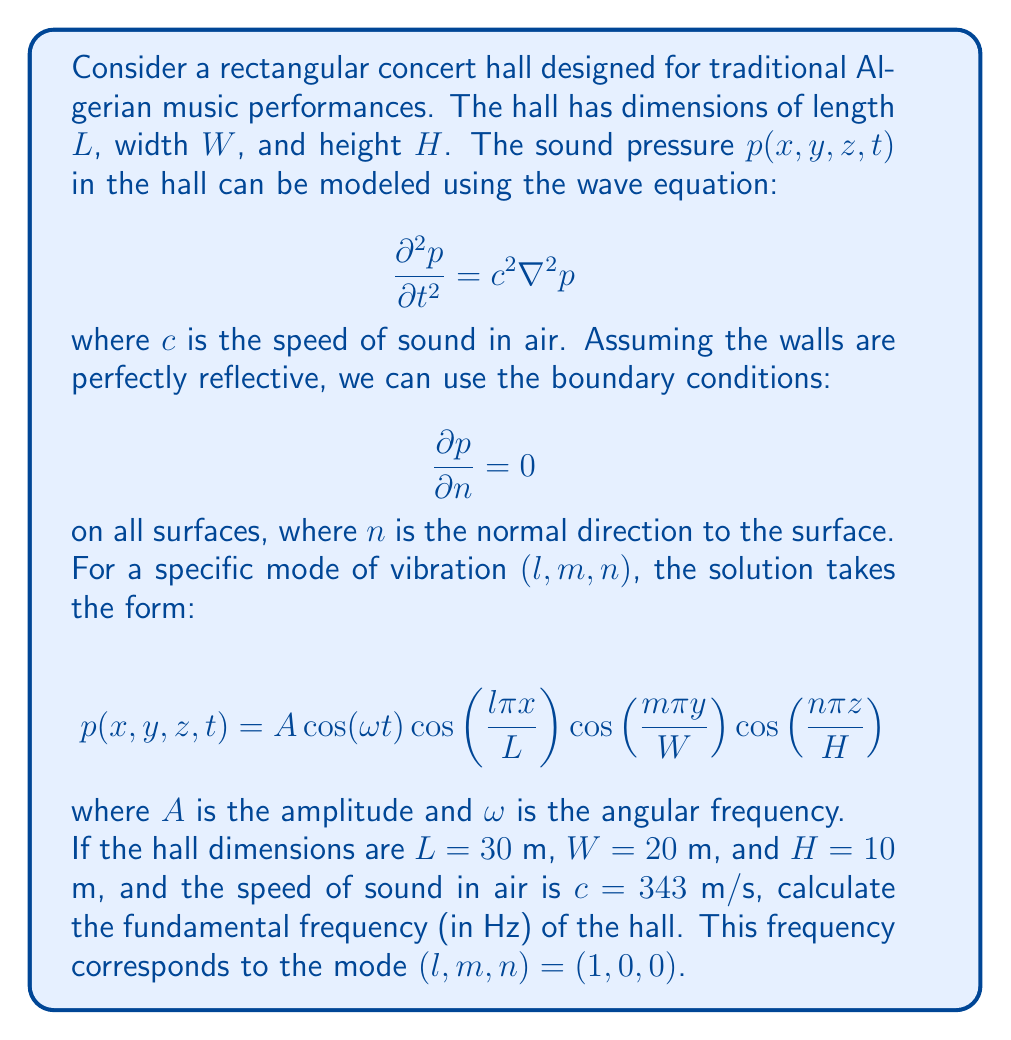Help me with this question. To solve this problem, we'll follow these steps:

1) The general relationship between frequency $f$, wavelength $\lambda$, and speed of sound $c$ is:
   
   $$c = f\lambda$$

2) For the fundamental mode $(1,0,0)$, the wavelength is twice the length of the hall:
   
   $$\lambda = 2L = 2(30\text{ m}) = 60\text{ m}$$

3) Substituting this into the equation from step 1:

   $$343\text{ m/s} = f(60\text{ m})$$

4) Solving for $f$:

   $$f = \frac{343\text{ m/s}}{60\text{ m}} = 5.7167\text{ Hz}$$

5) Rounding to two decimal places:

   $$f \approx 5.72\text{ Hz}$$

This frequency represents the fundamental mode of vibration along the length of the hall. It's particularly important for traditional Algerian music, which often features low-frequency instruments like the darbuka or bendir that could resonate with this fundamental frequency.
Answer: 5.72 Hz 